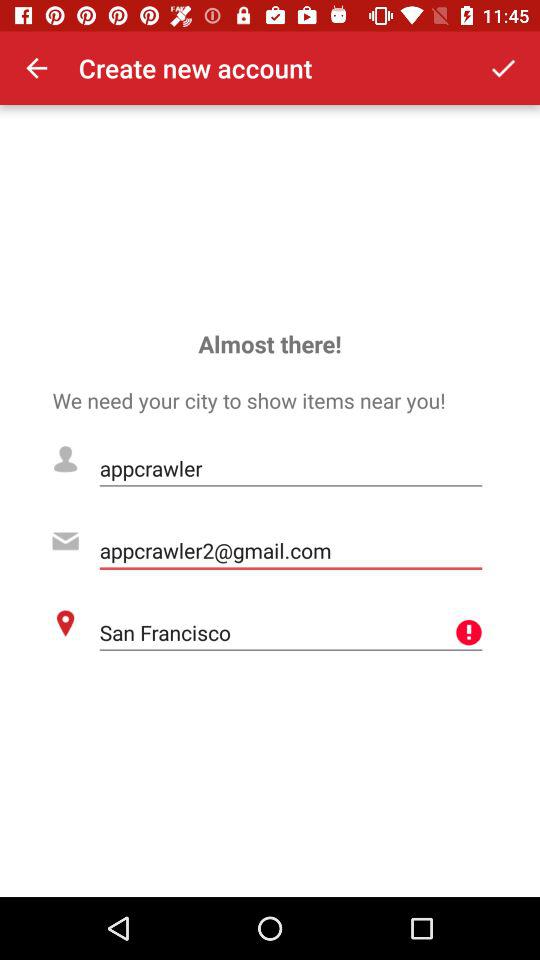What is the current location? The current location is San Francisco. 